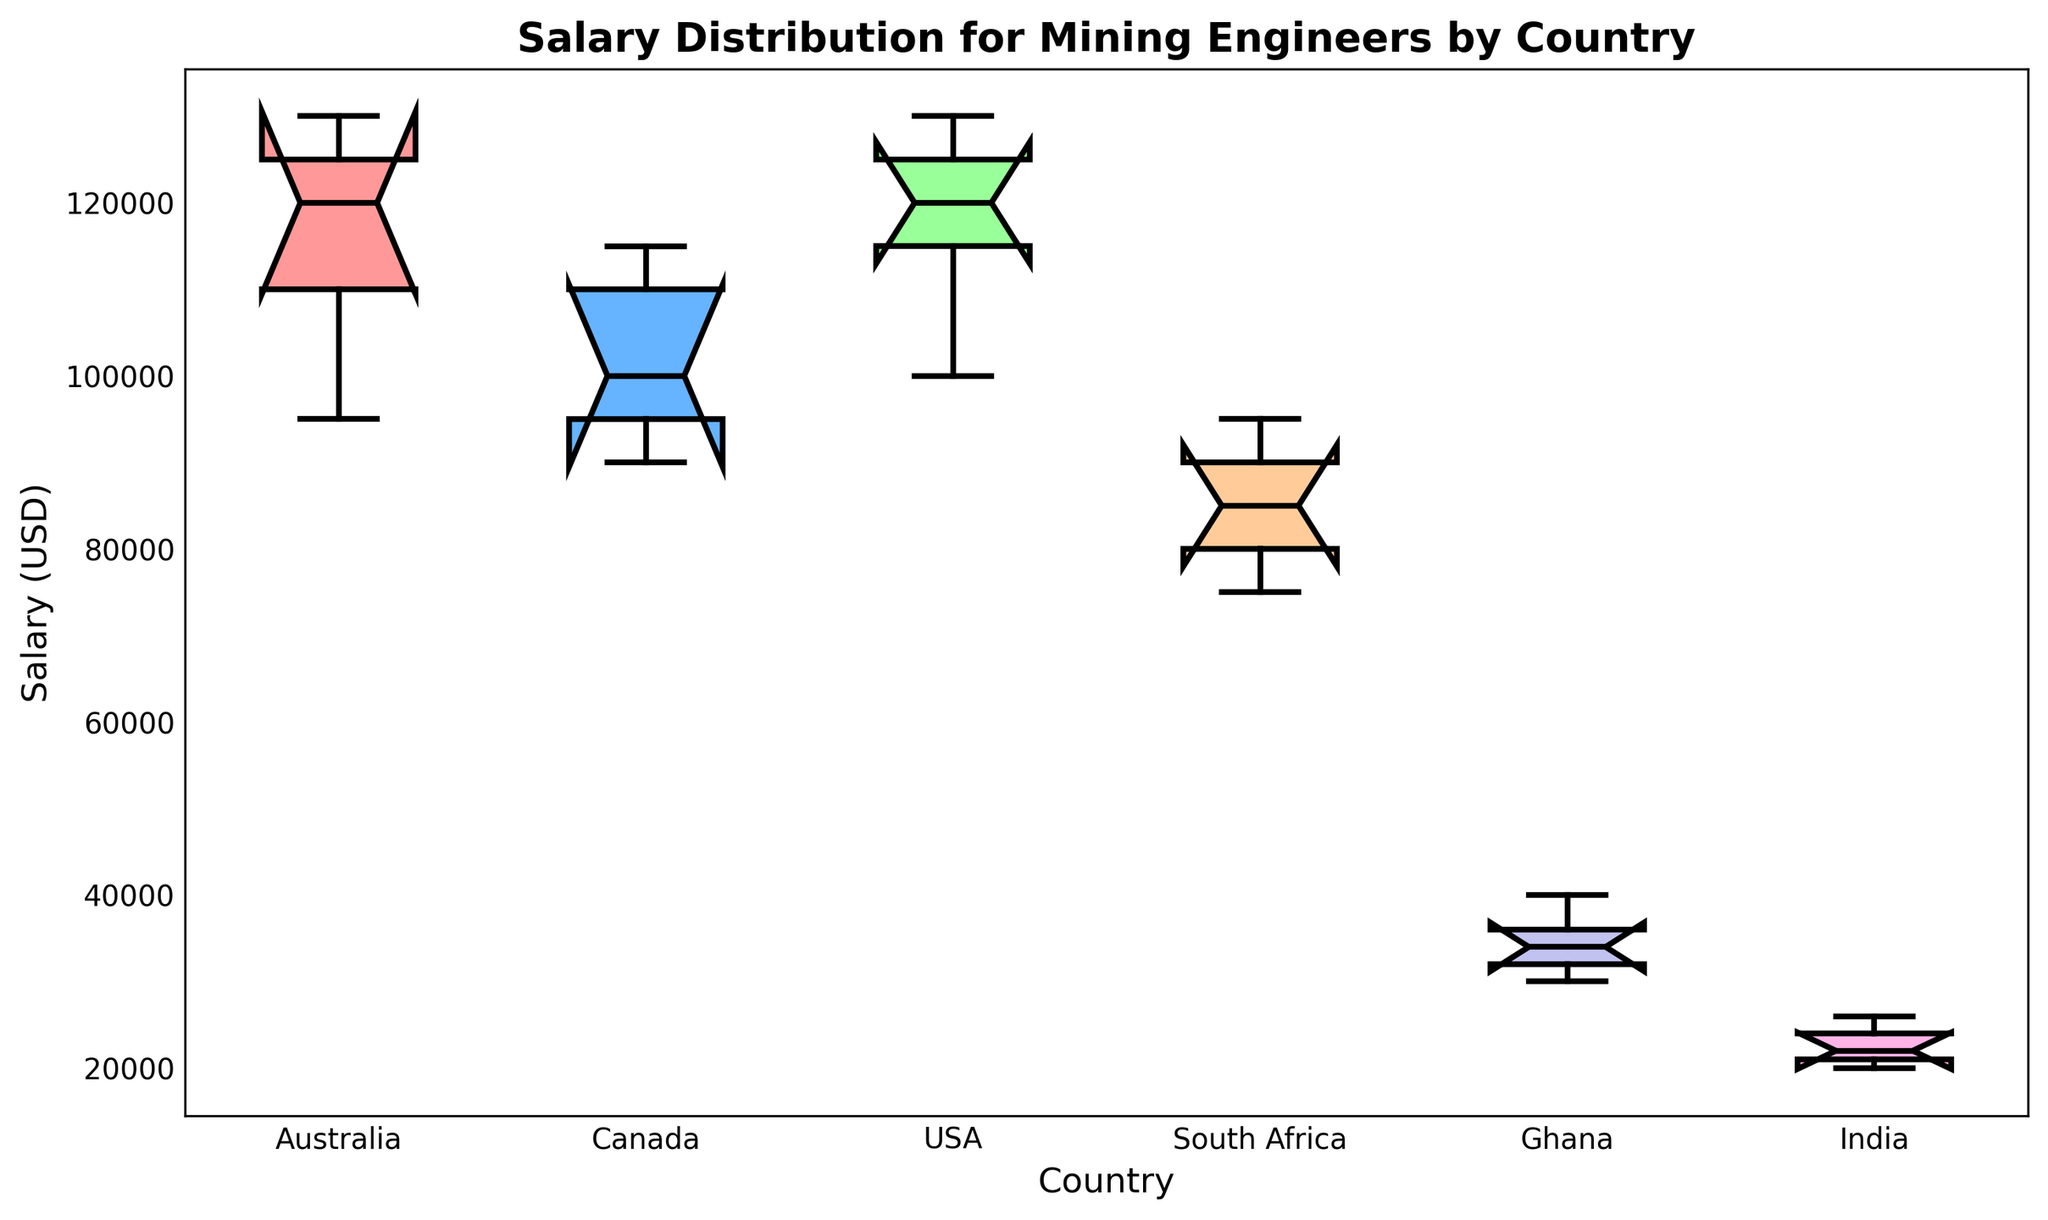Which country has the highest median salary for mining engineers? The median salary can be identified by looking at the line inside the box in the box plot. The USA has the highest median salary for mining engineers as its median line is higher than other countries.
Answer: USA Which country has the lowest median salary for mining engineers? The median salary can be identified by looking at the line inside the box in the box plot. India has the lowest median salary for mining engineers as its median line is lower than other countries.
Answer: India How does the interquartile range of Australia compare to that of Canada? The interquartile range (IQR) is the difference between the upper quartile (75th percentile) and the lower quartile (25th percentile). Australia's IQR is larger than Canada's, as the box (representing the IQR) for Australia is taller than that for Canada.
Answer: Australia's IQR is larger than Canada's Which country shows the widest range of salaries for mining engineers? The range of salaries can be observed by looking at the distance between the top whisker and the bottom whisker for each country. Australia has the widest range of salaries for mining engineers as the distance between its whiskers is the largest.
Answer: Australia Is there any country where the minimum salary overlaps with the median salary of another country? For overlap, the minimum salary whisker of one country should align with the median line of another. South Africa's minimum salary overlaps with the median salary of India.
Answer: Yes, South Africa and India Which country has the most consistent (least spread) salary distribution for mining engineers? The consistency or spread can be seen from the length of the box and the whiskers. India's box plot shows the least spread, indicating the most consistent salary distribution.
Answer: India How do the salaries of mining engineers in Ghana compare to those in South Africa? The median salary in South Africa is higher than in Ghana. Moreover, the overall salary distribution (considering box-and-whisker length) in South Africa is higher than in Ghana.
Answer: South Africa salaries are higher than Ghana's What is the difference between the median salaries of USA and Ghana? The median for the USA can be taken as approximately the middle value of its box plot, and similarly for Ghana. The USA median is around 120,000 and Ghana around 34,000. The difference is 120,000 - 34,000.
Answer: 86,000 What can be said about the outliers in the data? From the box plot, outliers are typically shown as individual points beyond the whiskers. There are no outliers shown in any of the countries’ salary distributions, indicating no extreme high/low salaries.
Answer: No outliers Is there any country where the third quartile is lower than the first quartile of another country? The third quartile is at the top of the box, and the first quartile at the bottom. Australia's third quartile is lower than the first quartile of the USA, meaning its highest earners make less than the least-paid in the USA.
Answer: Yes, Australia and USA 